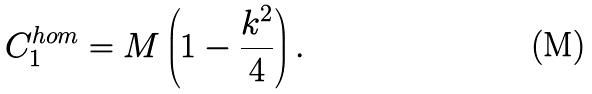Convert formula to latex. <formula><loc_0><loc_0><loc_500><loc_500>C _ { 1 } ^ { h o m } = M \left ( 1 - \frac { k ^ { 2 } } { 4 } \right ) .</formula> 